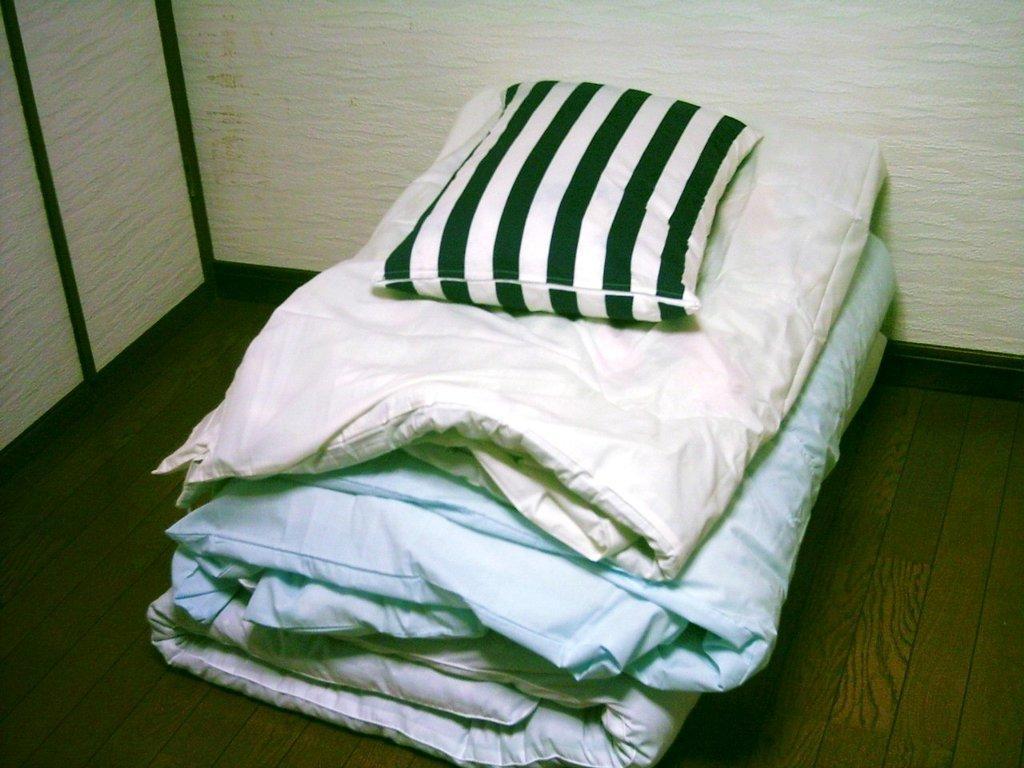Please provide a concise description of this image. In the picture I can see pillow and blankets on a wooden surface. In the background I can see white color walls. The pillow has black and white color design lines on it. 